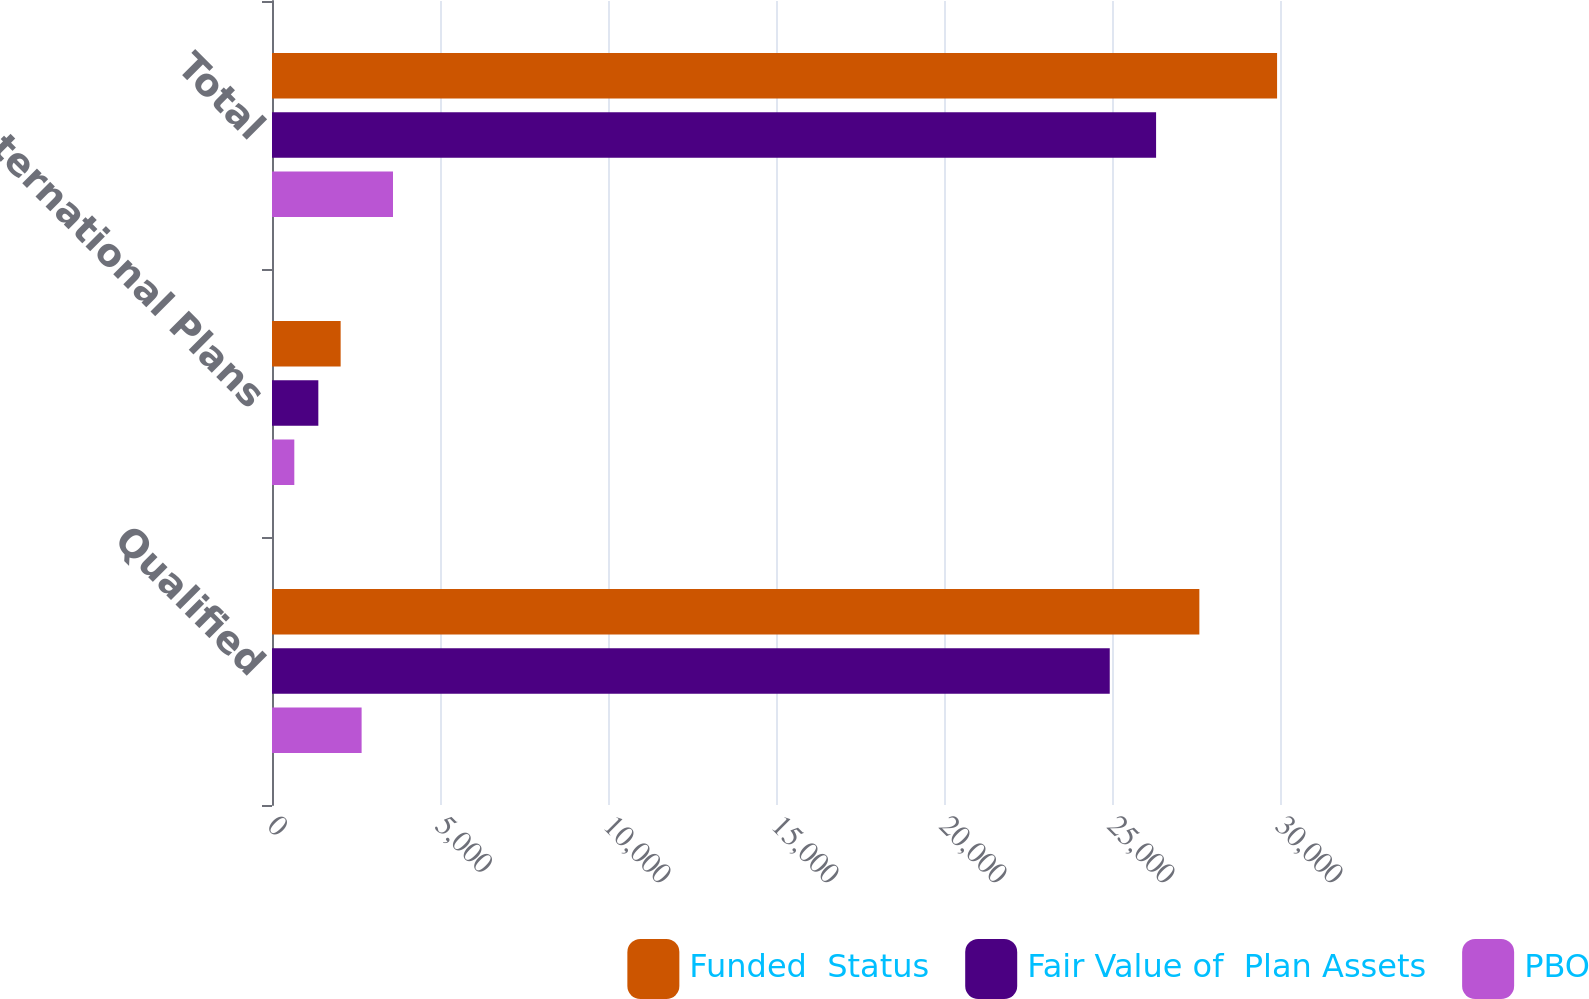Convert chart. <chart><loc_0><loc_0><loc_500><loc_500><stacked_bar_chart><ecel><fcel>Qualified<fcel>International Plans<fcel>Total<nl><fcel>Funded  Status<fcel>27600<fcel>2043<fcel>29913<nl><fcel>Fair Value of  Plan Assets<fcel>24933<fcel>1379<fcel>26312<nl><fcel>PBO<fcel>2667<fcel>664<fcel>3601<nl></chart> 